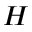Convert formula to latex. <formula><loc_0><loc_0><loc_500><loc_500>H</formula> 